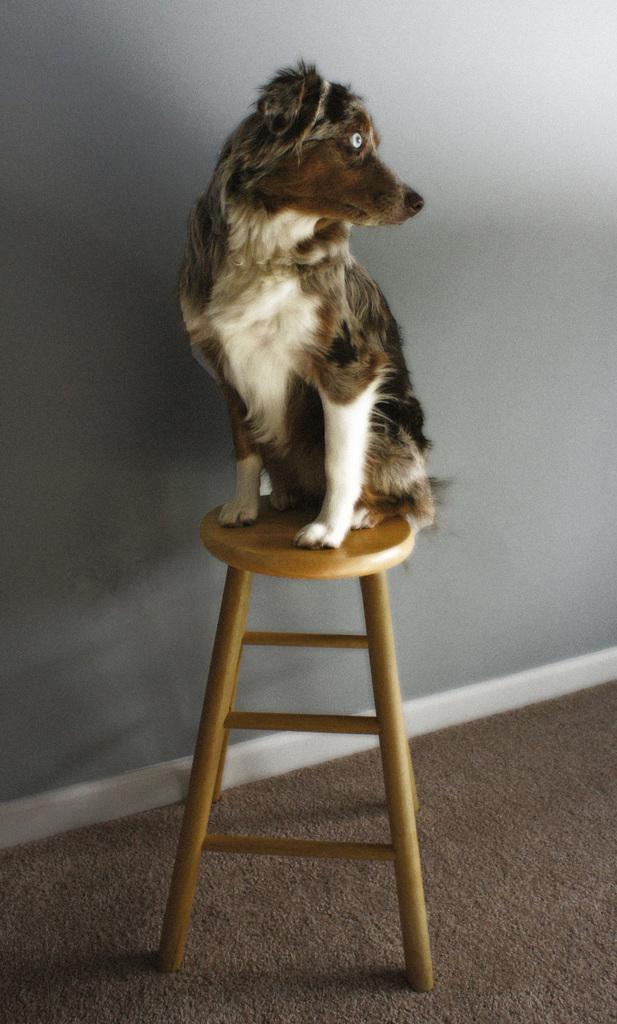Describe this image in one or two sentences. In this picture there is a dog on the stool. At the back there is a wall. At the bottom there is a mat. 